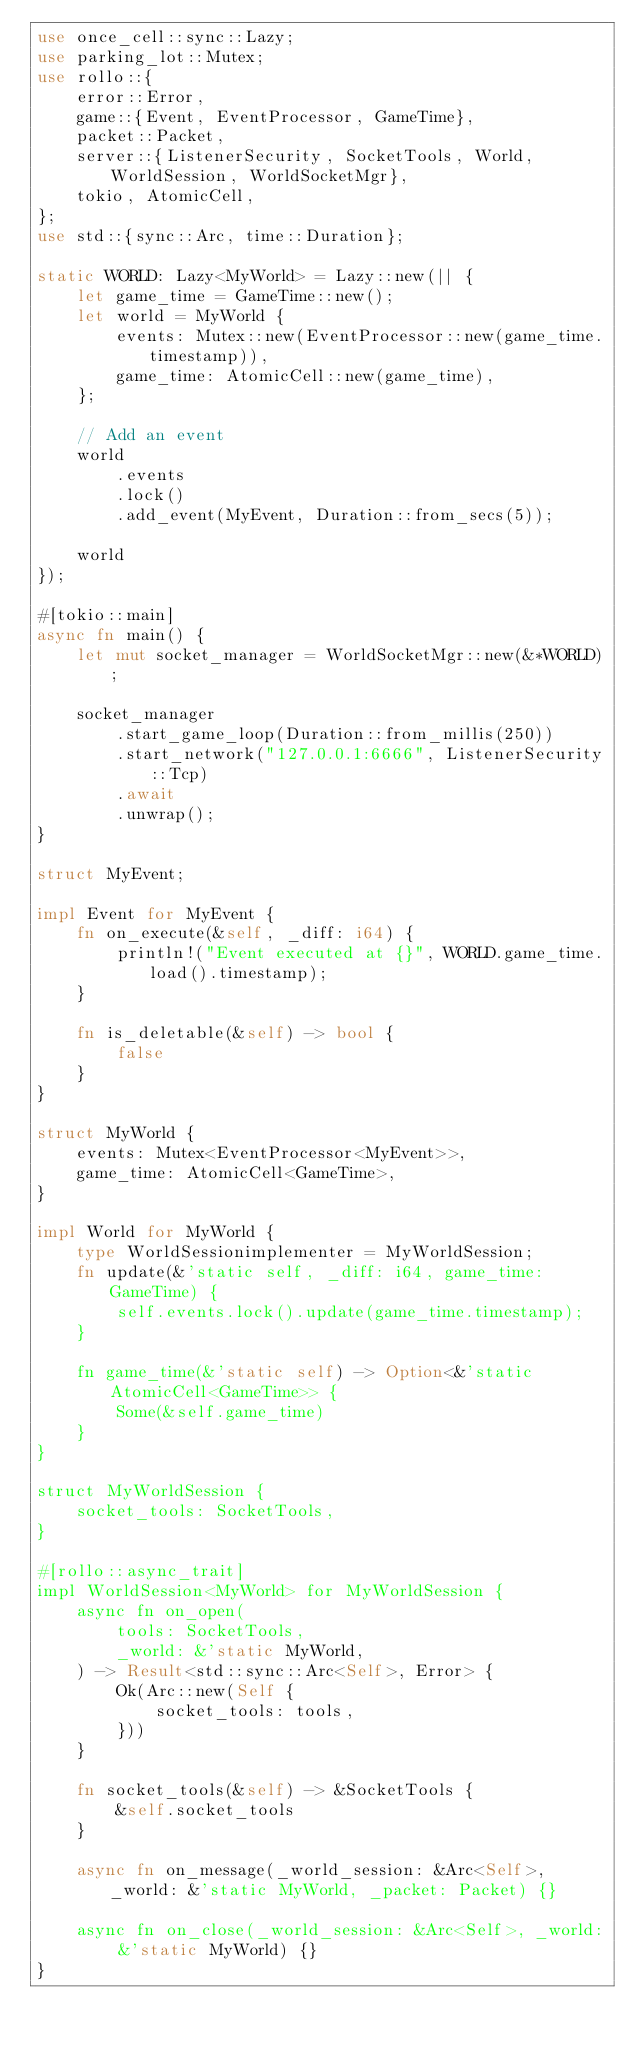Convert code to text. <code><loc_0><loc_0><loc_500><loc_500><_Rust_>use once_cell::sync::Lazy;
use parking_lot::Mutex;
use rollo::{
    error::Error,
    game::{Event, EventProcessor, GameTime},
    packet::Packet,
    server::{ListenerSecurity, SocketTools, World, WorldSession, WorldSocketMgr},
    tokio, AtomicCell,
};
use std::{sync::Arc, time::Duration};

static WORLD: Lazy<MyWorld> = Lazy::new(|| {
    let game_time = GameTime::new();
    let world = MyWorld {
        events: Mutex::new(EventProcessor::new(game_time.timestamp)),
        game_time: AtomicCell::new(game_time),
    };

    // Add an event
    world
        .events
        .lock()
        .add_event(MyEvent, Duration::from_secs(5));

    world
});

#[tokio::main]
async fn main() {
    let mut socket_manager = WorldSocketMgr::new(&*WORLD);

    socket_manager
        .start_game_loop(Duration::from_millis(250))
        .start_network("127.0.0.1:6666", ListenerSecurity::Tcp)
        .await
        .unwrap();
}

struct MyEvent;

impl Event for MyEvent {
    fn on_execute(&self, _diff: i64) {
        println!("Event executed at {}", WORLD.game_time.load().timestamp);
    }

    fn is_deletable(&self) -> bool {
        false
    }
}

struct MyWorld {
    events: Mutex<EventProcessor<MyEvent>>,
    game_time: AtomicCell<GameTime>,
}

impl World for MyWorld {
    type WorldSessionimplementer = MyWorldSession;
    fn update(&'static self, _diff: i64, game_time: GameTime) {
        self.events.lock().update(game_time.timestamp);
    }

    fn game_time(&'static self) -> Option<&'static AtomicCell<GameTime>> {
        Some(&self.game_time)
    }
}

struct MyWorldSession {
    socket_tools: SocketTools,
}

#[rollo::async_trait]
impl WorldSession<MyWorld> for MyWorldSession {
    async fn on_open(
        tools: SocketTools,
        _world: &'static MyWorld,
    ) -> Result<std::sync::Arc<Self>, Error> {
        Ok(Arc::new(Self {
            socket_tools: tools,
        }))
    }

    fn socket_tools(&self) -> &SocketTools {
        &self.socket_tools
    }

    async fn on_message(_world_session: &Arc<Self>, _world: &'static MyWorld, _packet: Packet) {}

    async fn on_close(_world_session: &Arc<Self>, _world: &'static MyWorld) {}
}
</code> 